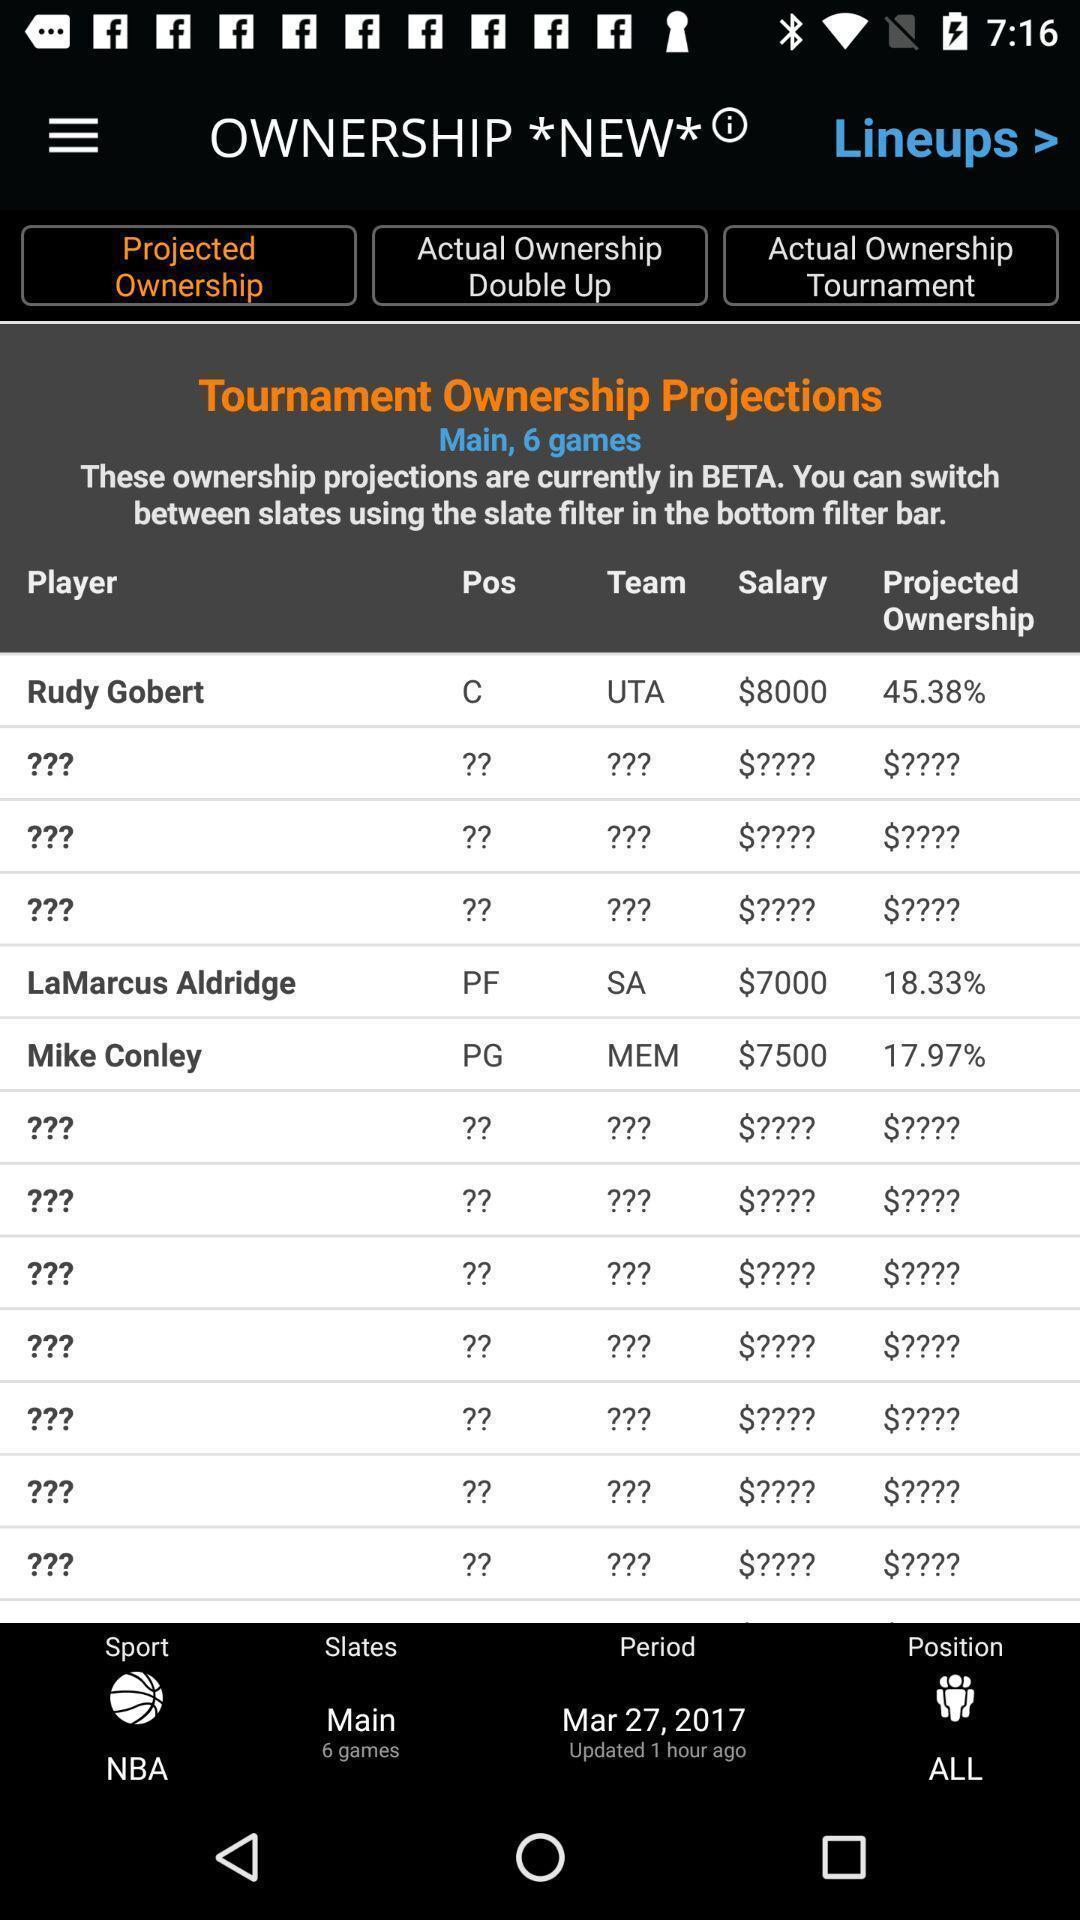Please provide a description for this image. Page shows the tournaments teams in a sports app. 